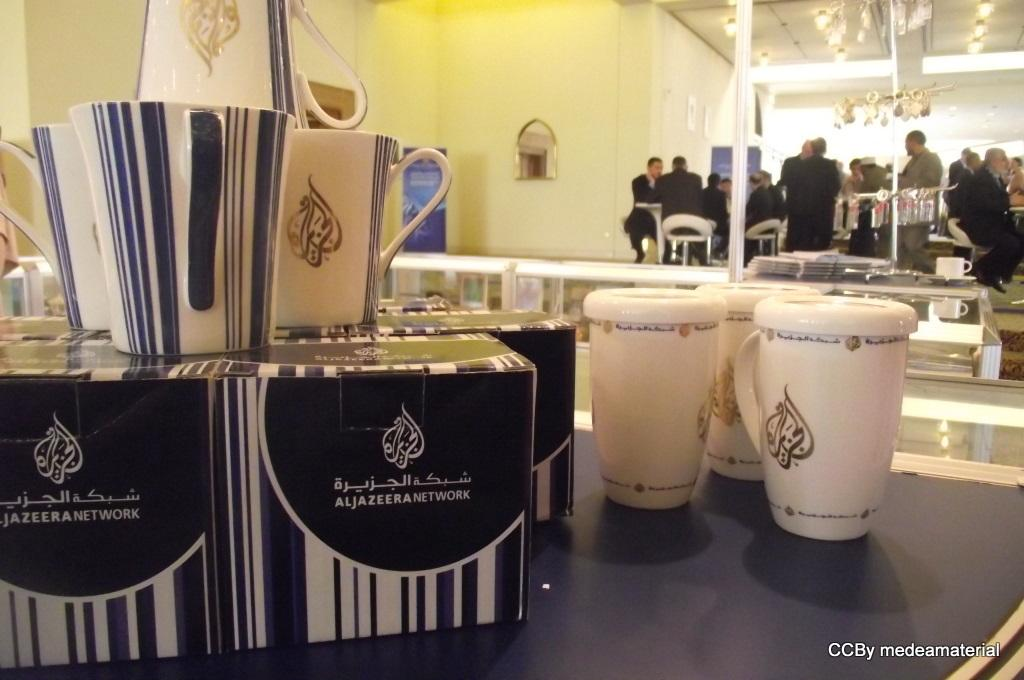<image>
Write a terse but informative summary of the picture. display of mugs, some boxed and unboxed for aljazeera network 